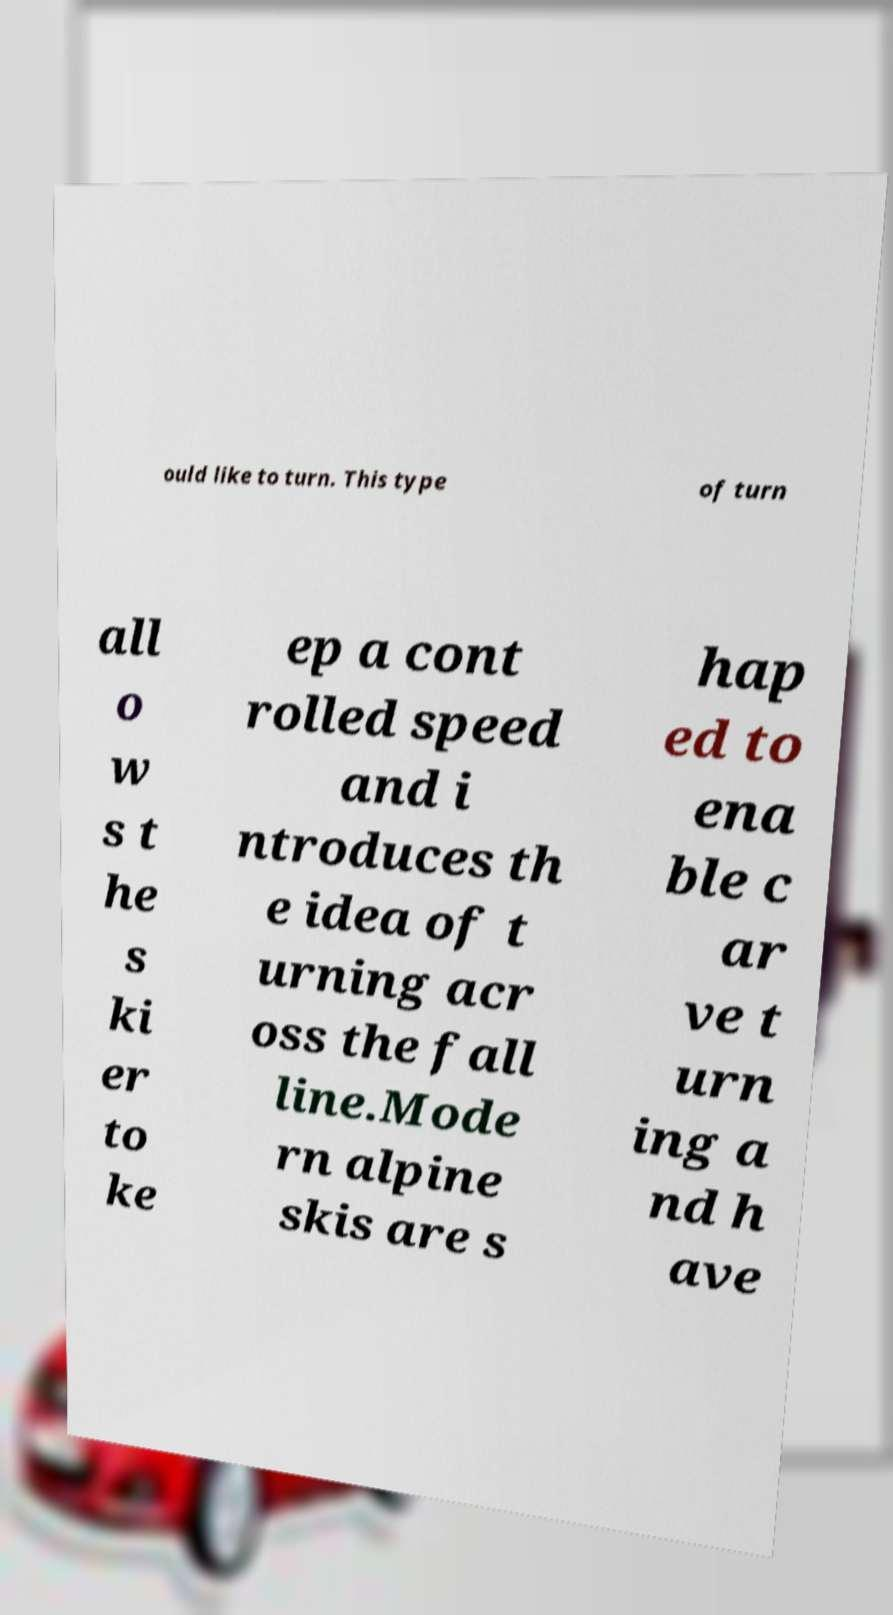Could you assist in decoding the text presented in this image and type it out clearly? ould like to turn. This type of turn all o w s t he s ki er to ke ep a cont rolled speed and i ntroduces th e idea of t urning acr oss the fall line.Mode rn alpine skis are s hap ed to ena ble c ar ve t urn ing a nd h ave 